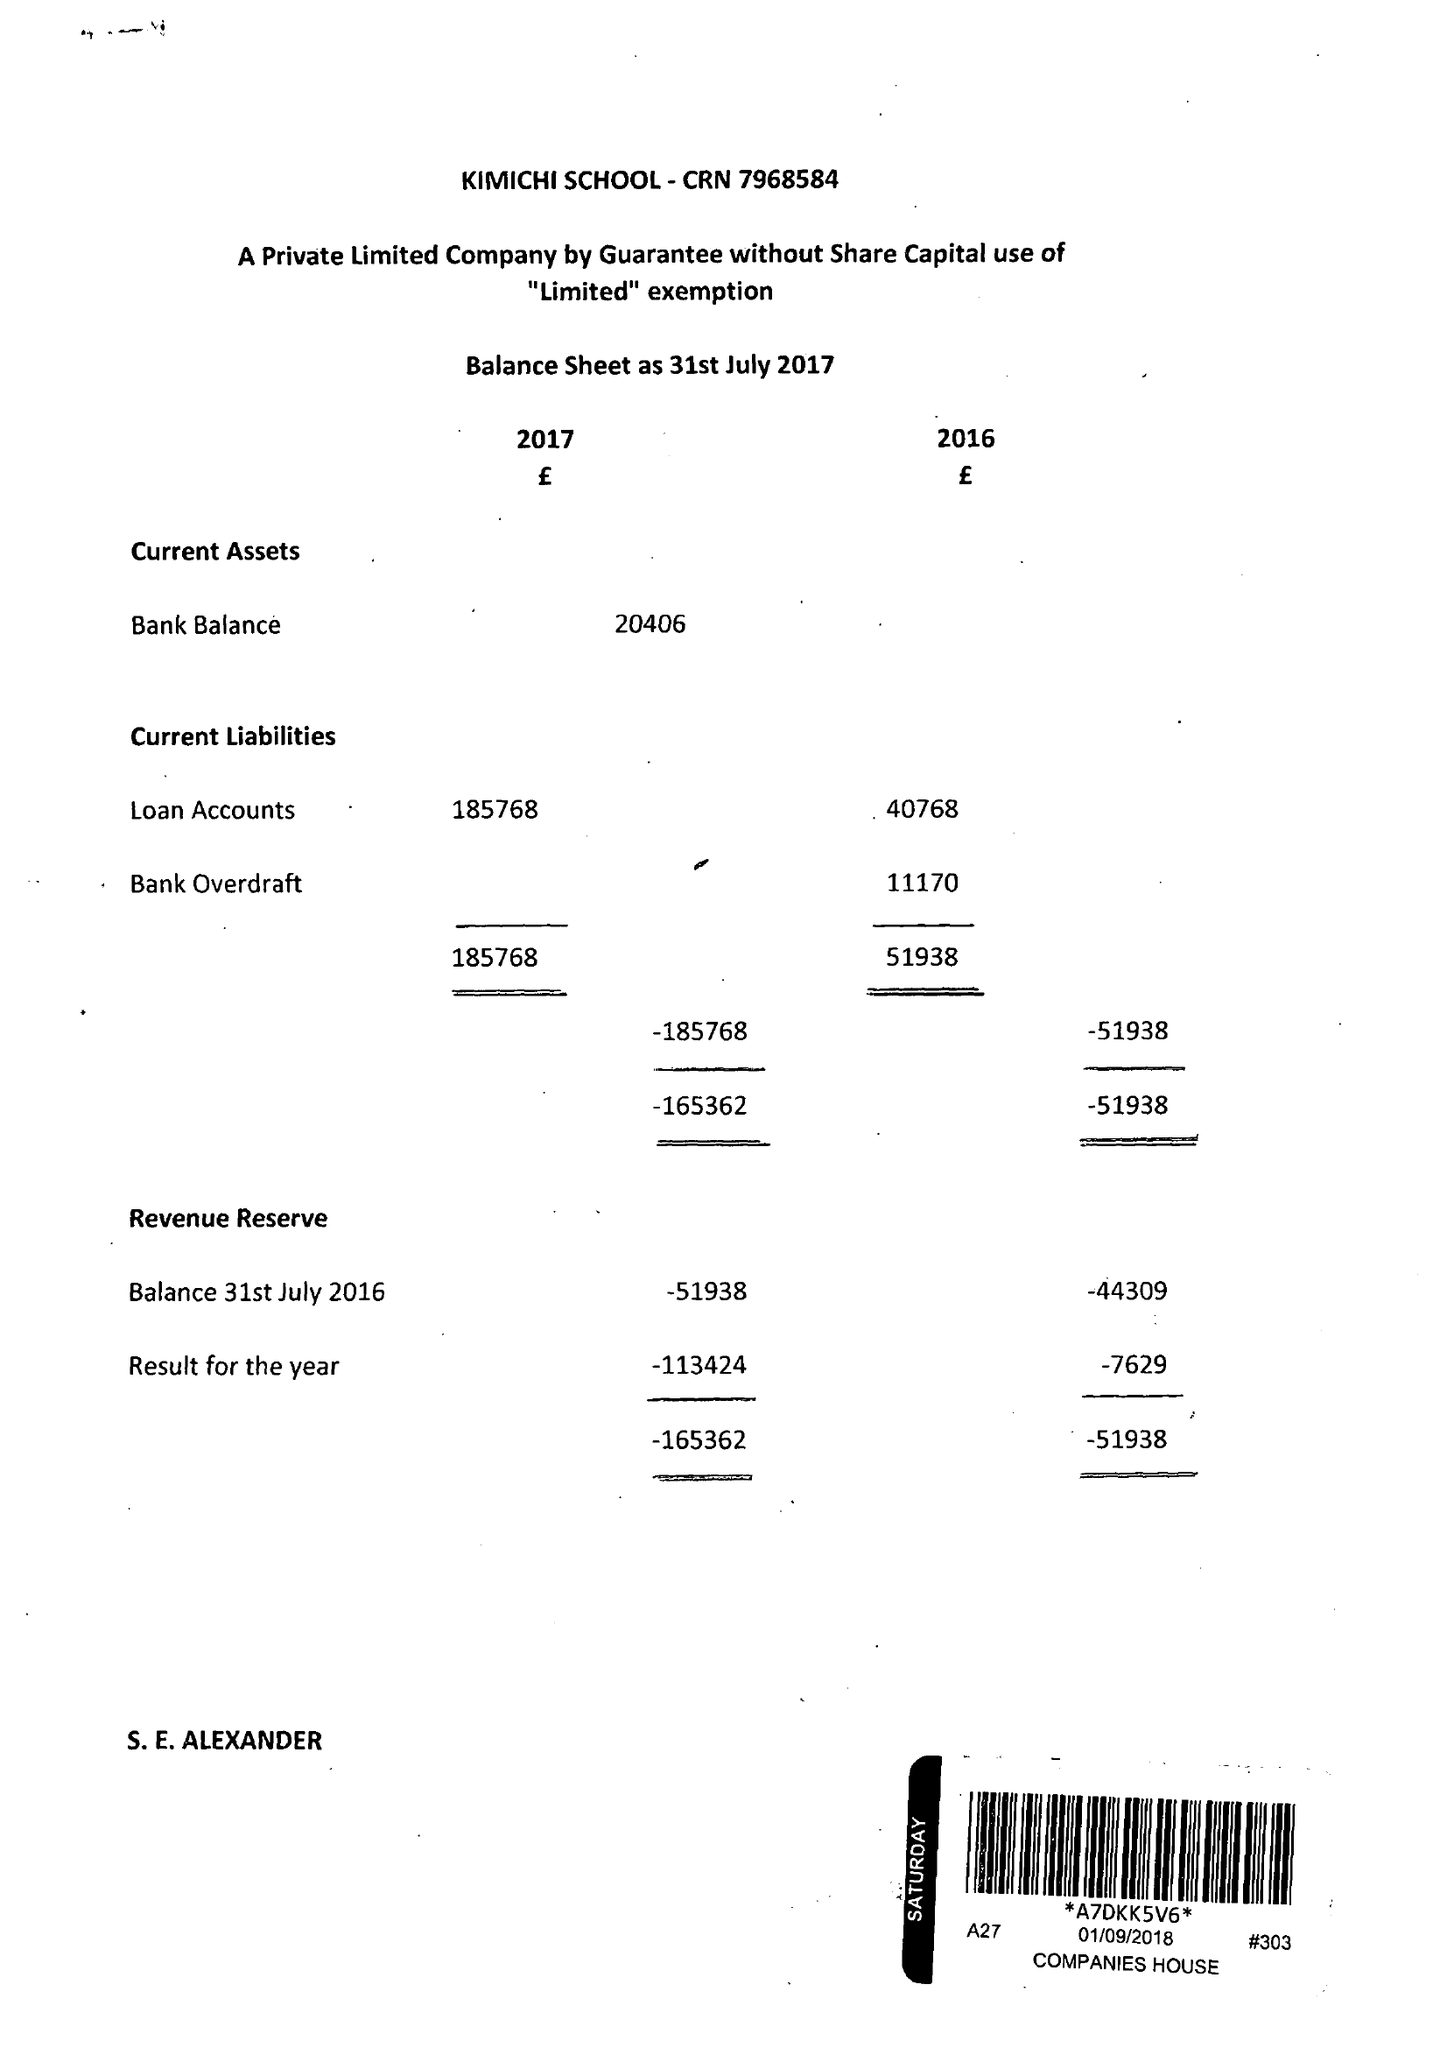What is the value for the charity_name?
Answer the question using a single word or phrase. Kimichi School 